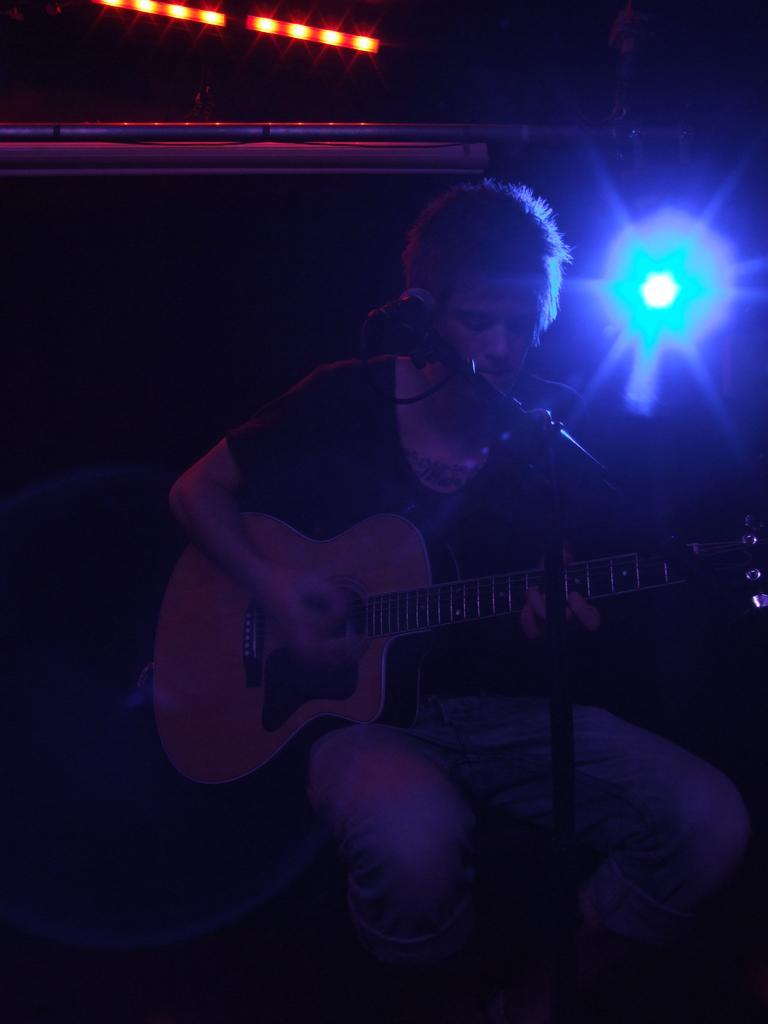In one or two sentences, can you explain what this image depicts? In this image, In the middle there is a person sitting and he is holding a music instrument which is in yellow ,There is a microphone which is in black color, In the background there is a light which is in blue and green color. 